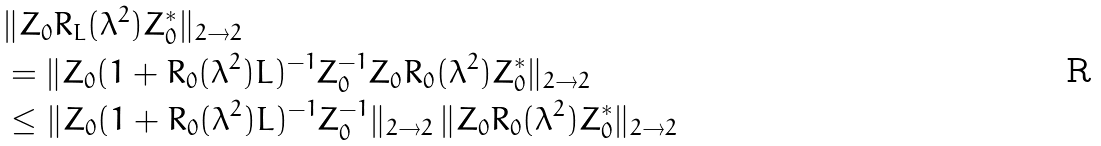<formula> <loc_0><loc_0><loc_500><loc_500>& \| Z _ { 0 } R _ { L } ( \lambda ^ { 2 } ) Z _ { 0 } ^ { * } \| _ { 2 \to 2 } \\ & = \| Z _ { 0 } ( 1 + R _ { 0 } ( \lambda ^ { 2 } ) L ) ^ { - 1 } Z _ { 0 } ^ { - 1 } Z _ { 0 } R _ { 0 } ( \lambda ^ { 2 } ) Z _ { 0 } ^ { * } \| _ { 2 \to 2 } \\ & \leq \| Z _ { 0 } ( 1 + R _ { 0 } ( \lambda ^ { 2 } ) L ) ^ { - 1 } Z _ { 0 } ^ { - 1 } \| _ { 2 \to 2 } \, \| Z _ { 0 } R _ { 0 } ( \lambda ^ { 2 } ) Z _ { 0 } ^ { * } \| _ { 2 \to 2 }</formula> 